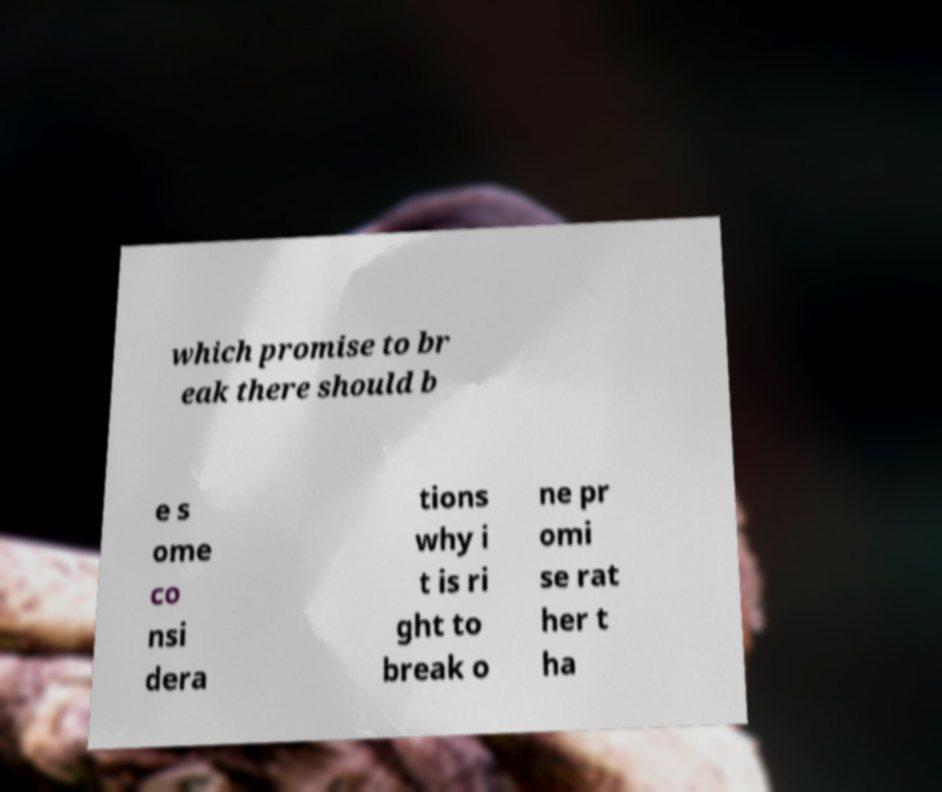What messages or text are displayed in this image? I need them in a readable, typed format. which promise to br eak there should b e s ome co nsi dera tions why i t is ri ght to break o ne pr omi se rat her t ha 